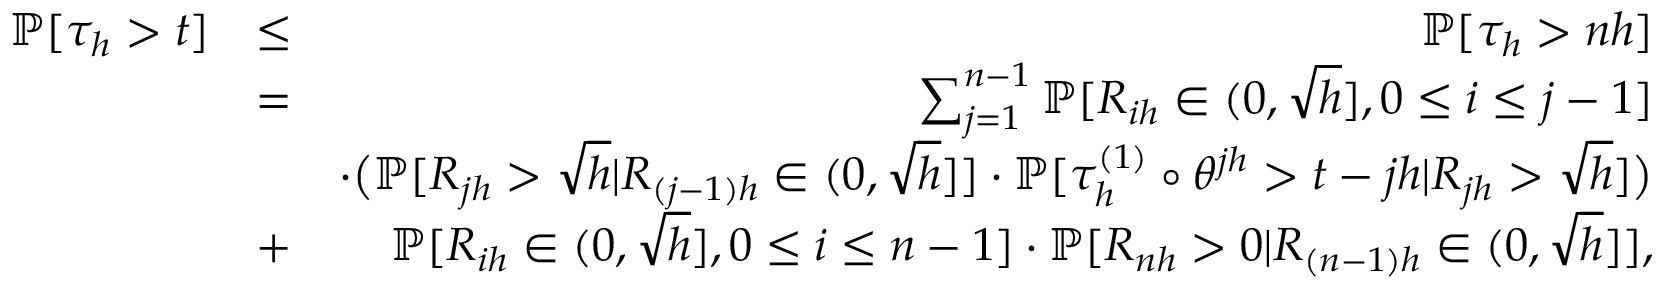<formula> <loc_0><loc_0><loc_500><loc_500>\begin{array} { r l r } { \mathbb { P } [ \tau _ { h } > t ] } & { \leq } & { \mathbb { P } [ \tau _ { h } > n h ] } \\ & { = } & { \sum _ { j = 1 } ^ { n - 1 } \mathbb { P } [ R _ { i h } \in ( 0 , \sqrt { h } ] , 0 \leq i \leq j - 1 ] } \\ & { \cdot \left ( \mathbb { P } [ R _ { j h } > \sqrt { h } | R _ { ( j - 1 ) h } \in ( 0 , \sqrt { h } ] ] \cdot \mathbb { P } [ \tau _ { h } ^ { ( 1 ) } \circ \theta ^ { j h } > t - j h | R _ { j h } > \sqrt { h } ] \right ) } \\ & { + } & { \mathbb { P } [ R _ { i h } \in ( 0 , \sqrt { h } ] , 0 \leq i \leq n - 1 ] \cdot \mathbb { P } [ R _ { n h } > 0 | R _ { ( n - 1 ) h } \in ( 0 , \sqrt { h } ] ] , } \end{array}</formula> 